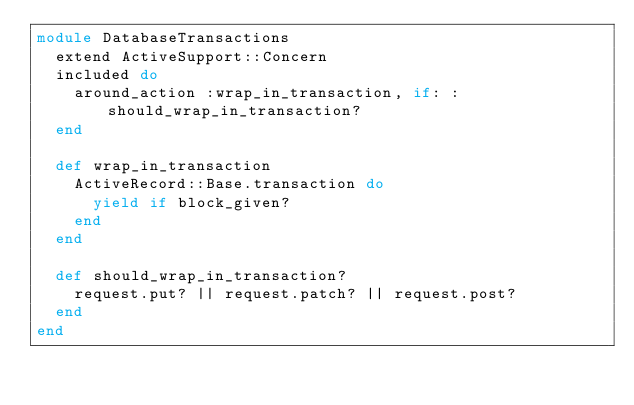Convert code to text. <code><loc_0><loc_0><loc_500><loc_500><_Ruby_>module DatabaseTransactions
  extend ActiveSupport::Concern
  included do
    around_action :wrap_in_transaction, if: :should_wrap_in_transaction?
  end

  def wrap_in_transaction
    ActiveRecord::Base.transaction do
      yield if block_given?
    end
  end

  def should_wrap_in_transaction?
    request.put? || request.patch? || request.post?
  end
end</code> 